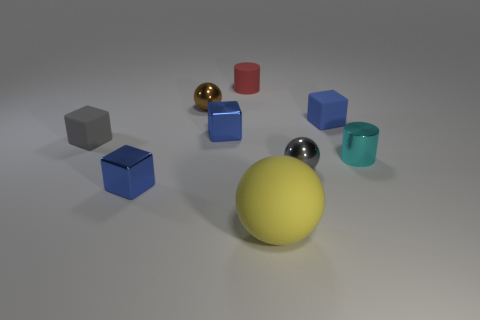The gray matte thing has what shape?
Offer a very short reply. Cube. Do the shiny cube behind the tiny cyan shiny cylinder and the tiny rubber cylinder have the same color?
Offer a terse response. No. The small shiny object that is both in front of the tiny cyan cylinder and on the left side of the big matte object has what shape?
Your answer should be very brief. Cube. There is a tiny metal ball on the right side of the large yellow rubber ball; what is its color?
Provide a short and direct response. Gray. Is there any other thing that has the same color as the rubber sphere?
Give a very brief answer. No. Does the gray metal sphere have the same size as the red thing?
Your answer should be very brief. Yes. What is the size of the ball that is both in front of the tiny blue rubber cube and behind the big sphere?
Your answer should be very brief. Small. What number of small cubes have the same material as the small red thing?
Provide a short and direct response. 2. What is the color of the metal cylinder?
Provide a short and direct response. Cyan. There is a tiny gray thing on the left side of the red matte object; is its shape the same as the gray metallic object?
Ensure brevity in your answer.  No. 